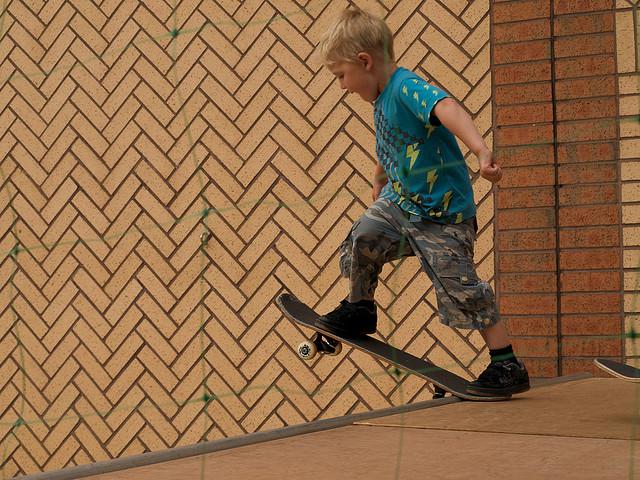What are the yellow symbols on the child's shirt?
Give a very brief answer. Lightning bolts. Is this person male or female?
Short answer required. Male. Is this a professional skater?
Quick response, please. No. What color are the wheels on the skateboard?
Be succinct. White. What is this child standing on?
Short answer required. Skateboard. Is the weather hot?
Answer briefly. Yes. What is the boy doing?
Give a very brief answer. Skateboarding. 